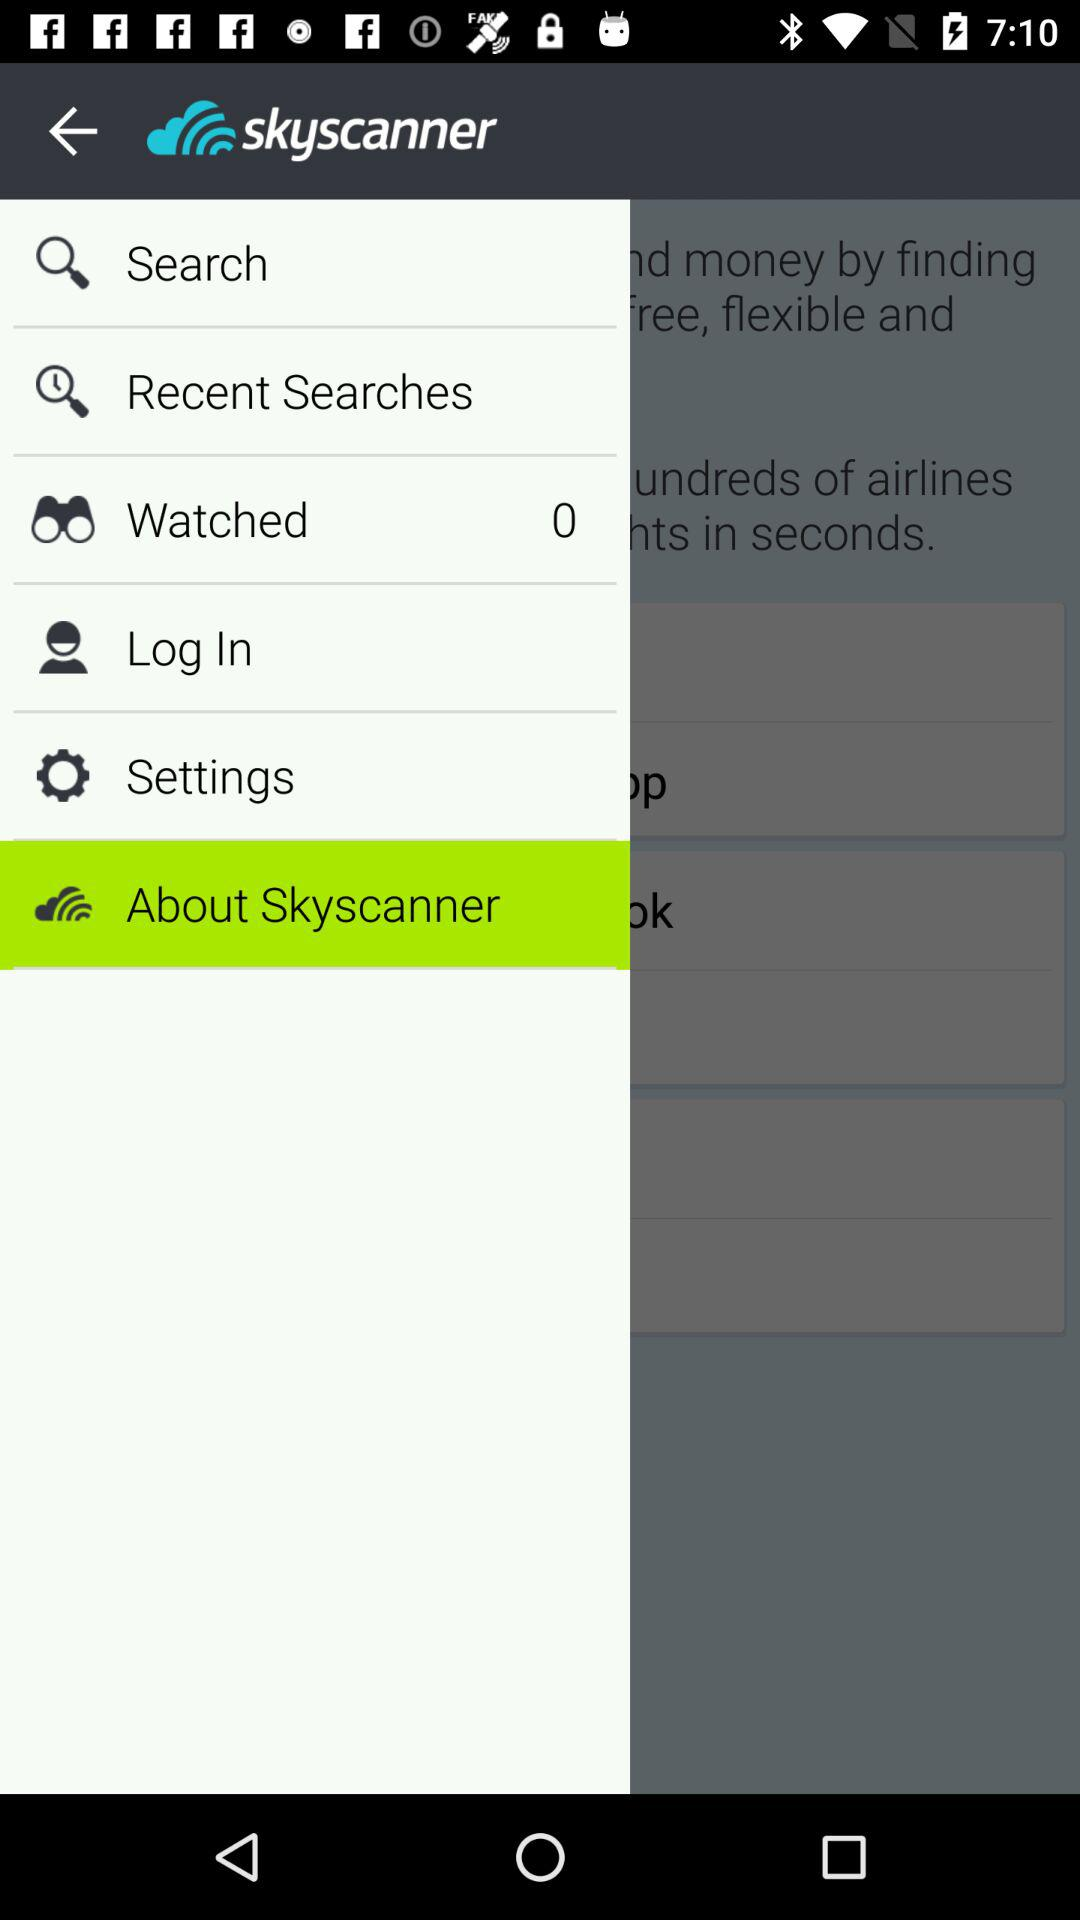What is the total number of "Watched"? The total number of "Watched" is 0. 